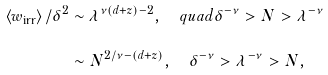<formula> <loc_0><loc_0><loc_500><loc_500>\left \langle w _ { \text {irr} } \right \rangle / \delta ^ { 2 } & \sim \lambda ^ { \nu \left ( d + z \right ) - 2 } , \quad q u a d \delta ^ { - \nu } > N > \lambda ^ { - \nu } \\ & \sim N ^ { 2 / \nu - \left ( d + z \right ) } , \quad \delta ^ { - \nu } > \lambda ^ { - \nu } > N ,</formula> 